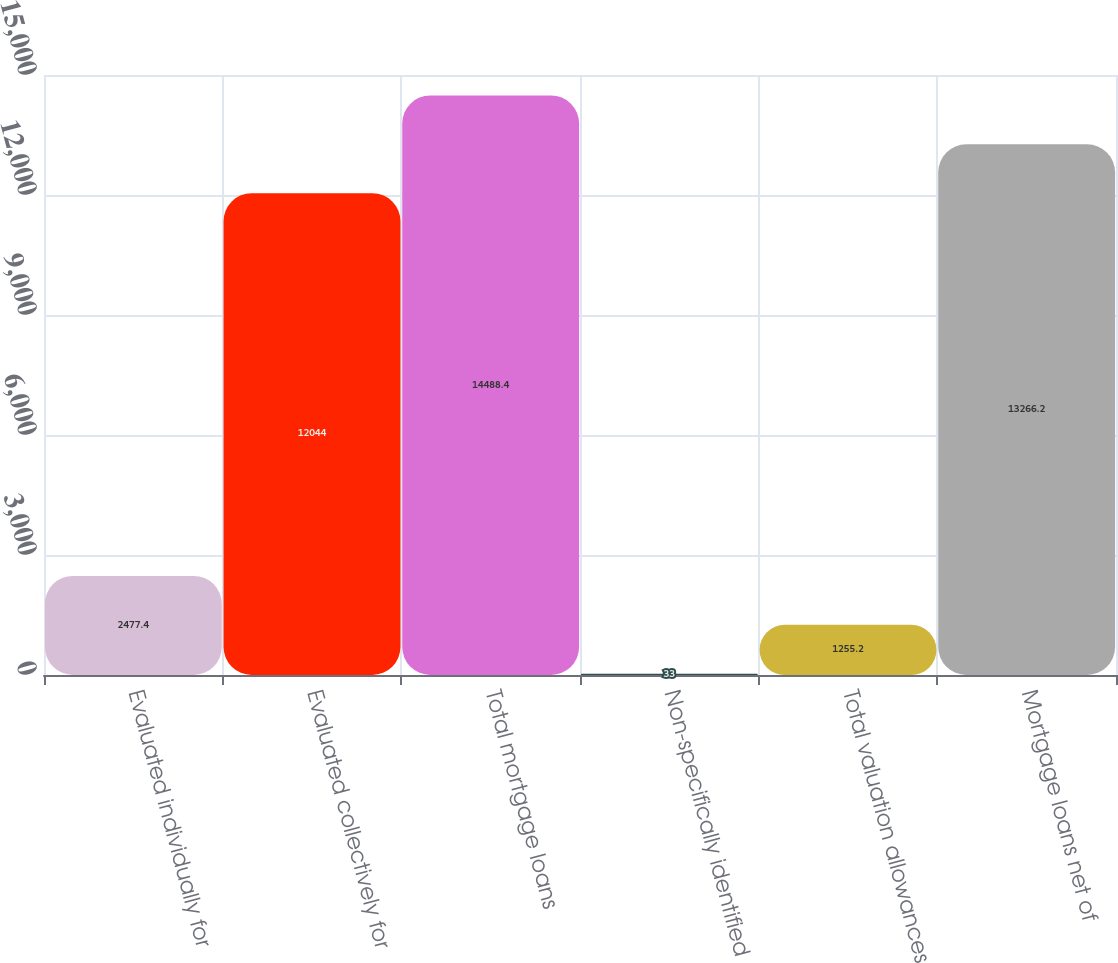<chart> <loc_0><loc_0><loc_500><loc_500><bar_chart><fcel>Evaluated individually for<fcel>Evaluated collectively for<fcel>Total mortgage loans<fcel>Non-specifically identified<fcel>Total valuation allowances<fcel>Mortgage loans net of<nl><fcel>2477.4<fcel>12044<fcel>14488.4<fcel>33<fcel>1255.2<fcel>13266.2<nl></chart> 